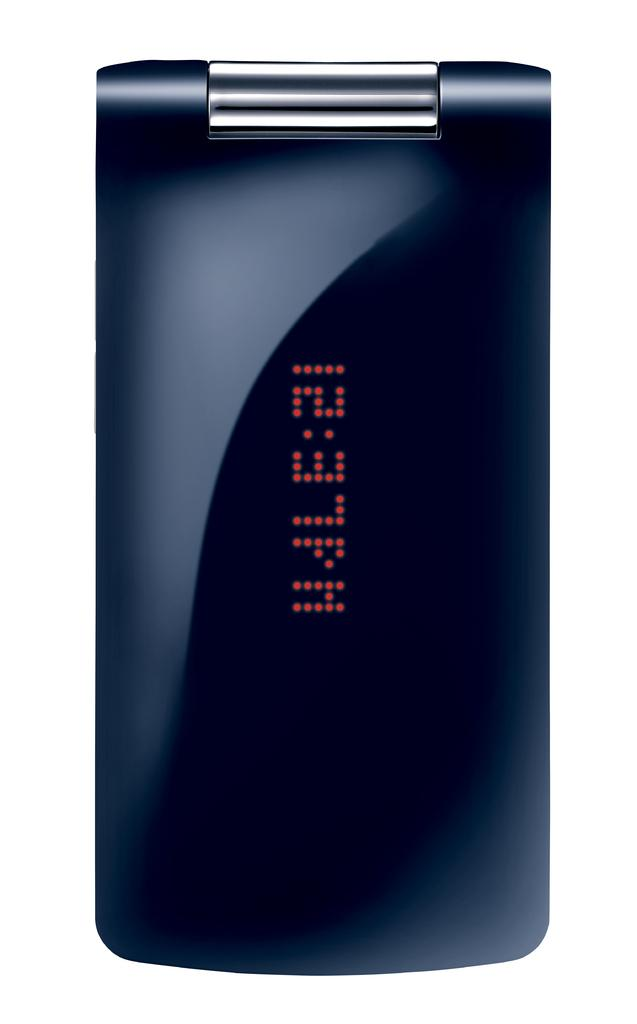<image>
Describe the image concisely. A closed electronic device has a time display on the cover. 